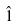Convert formula to latex. <formula><loc_0><loc_0><loc_500><loc_500>\hat { 1 }</formula> 